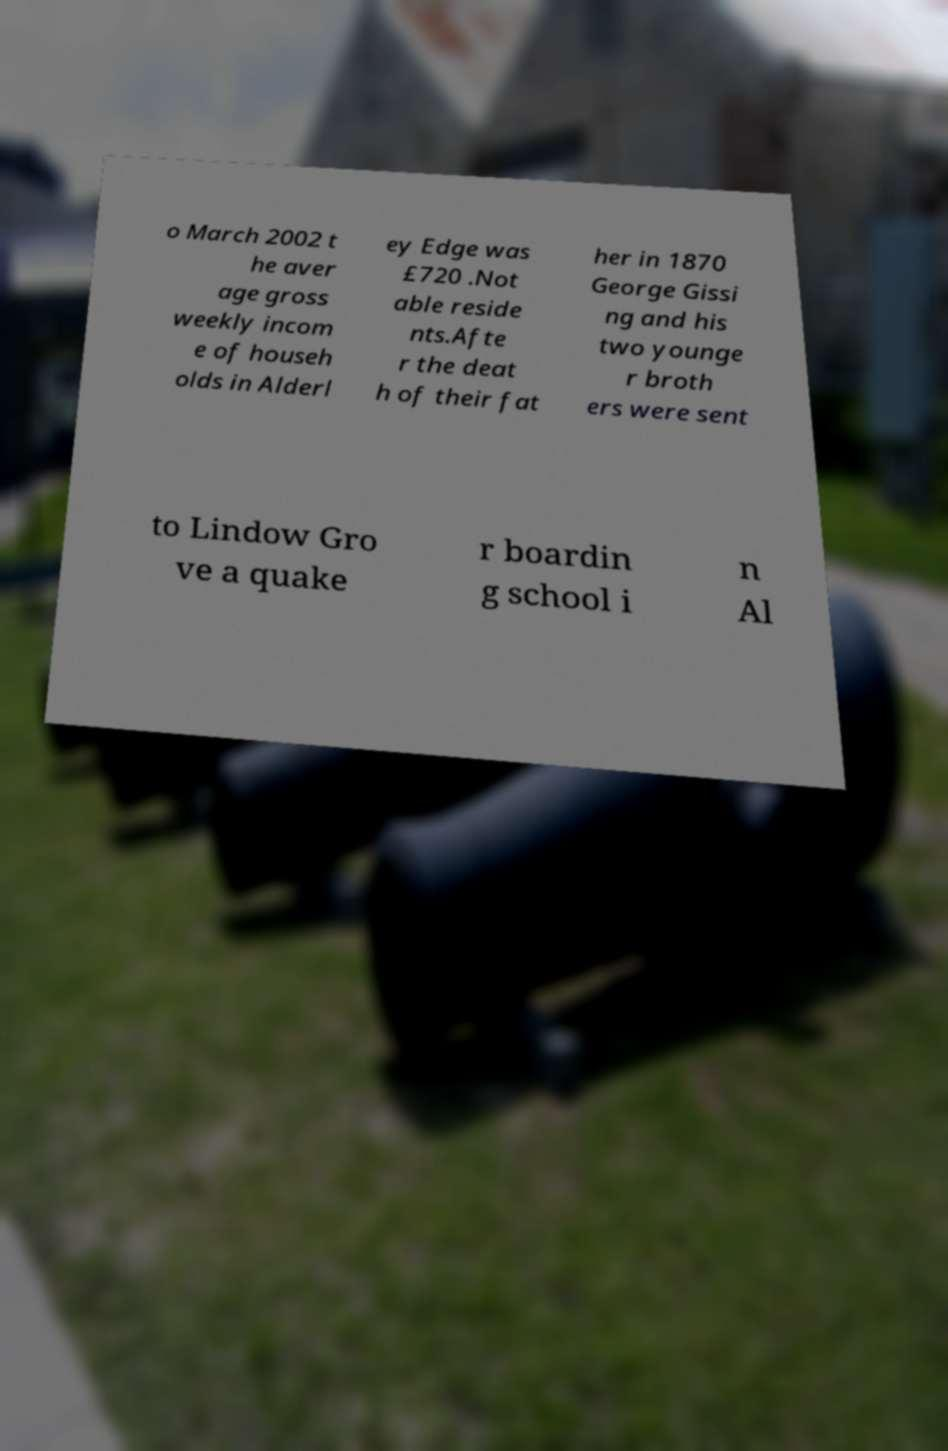I need the written content from this picture converted into text. Can you do that? o March 2002 t he aver age gross weekly incom e of househ olds in Alderl ey Edge was £720 .Not able reside nts.Afte r the deat h of their fat her in 1870 George Gissi ng and his two younge r broth ers were sent to Lindow Gro ve a quake r boardin g school i n Al 